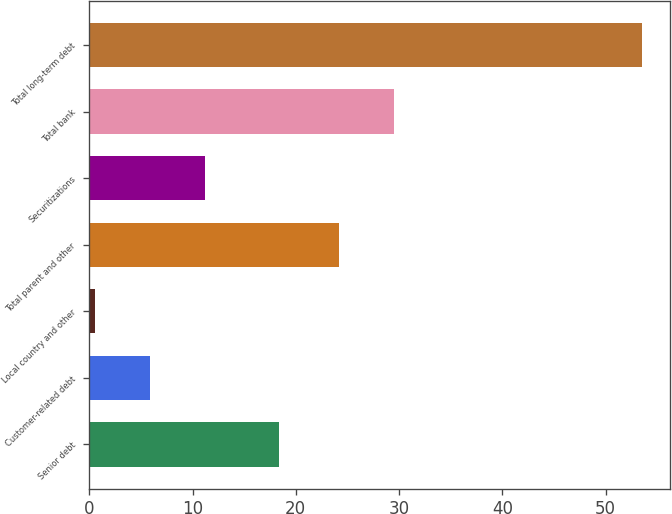Convert chart to OTSL. <chart><loc_0><loc_0><loc_500><loc_500><bar_chart><fcel>Senior debt<fcel>Customer-related debt<fcel>Local country and other<fcel>Total parent and other<fcel>Securitizations<fcel>Total bank<fcel>Total long-term debt<nl><fcel>18.4<fcel>5.89<fcel>0.6<fcel>24.2<fcel>11.18<fcel>29.49<fcel>53.5<nl></chart> 